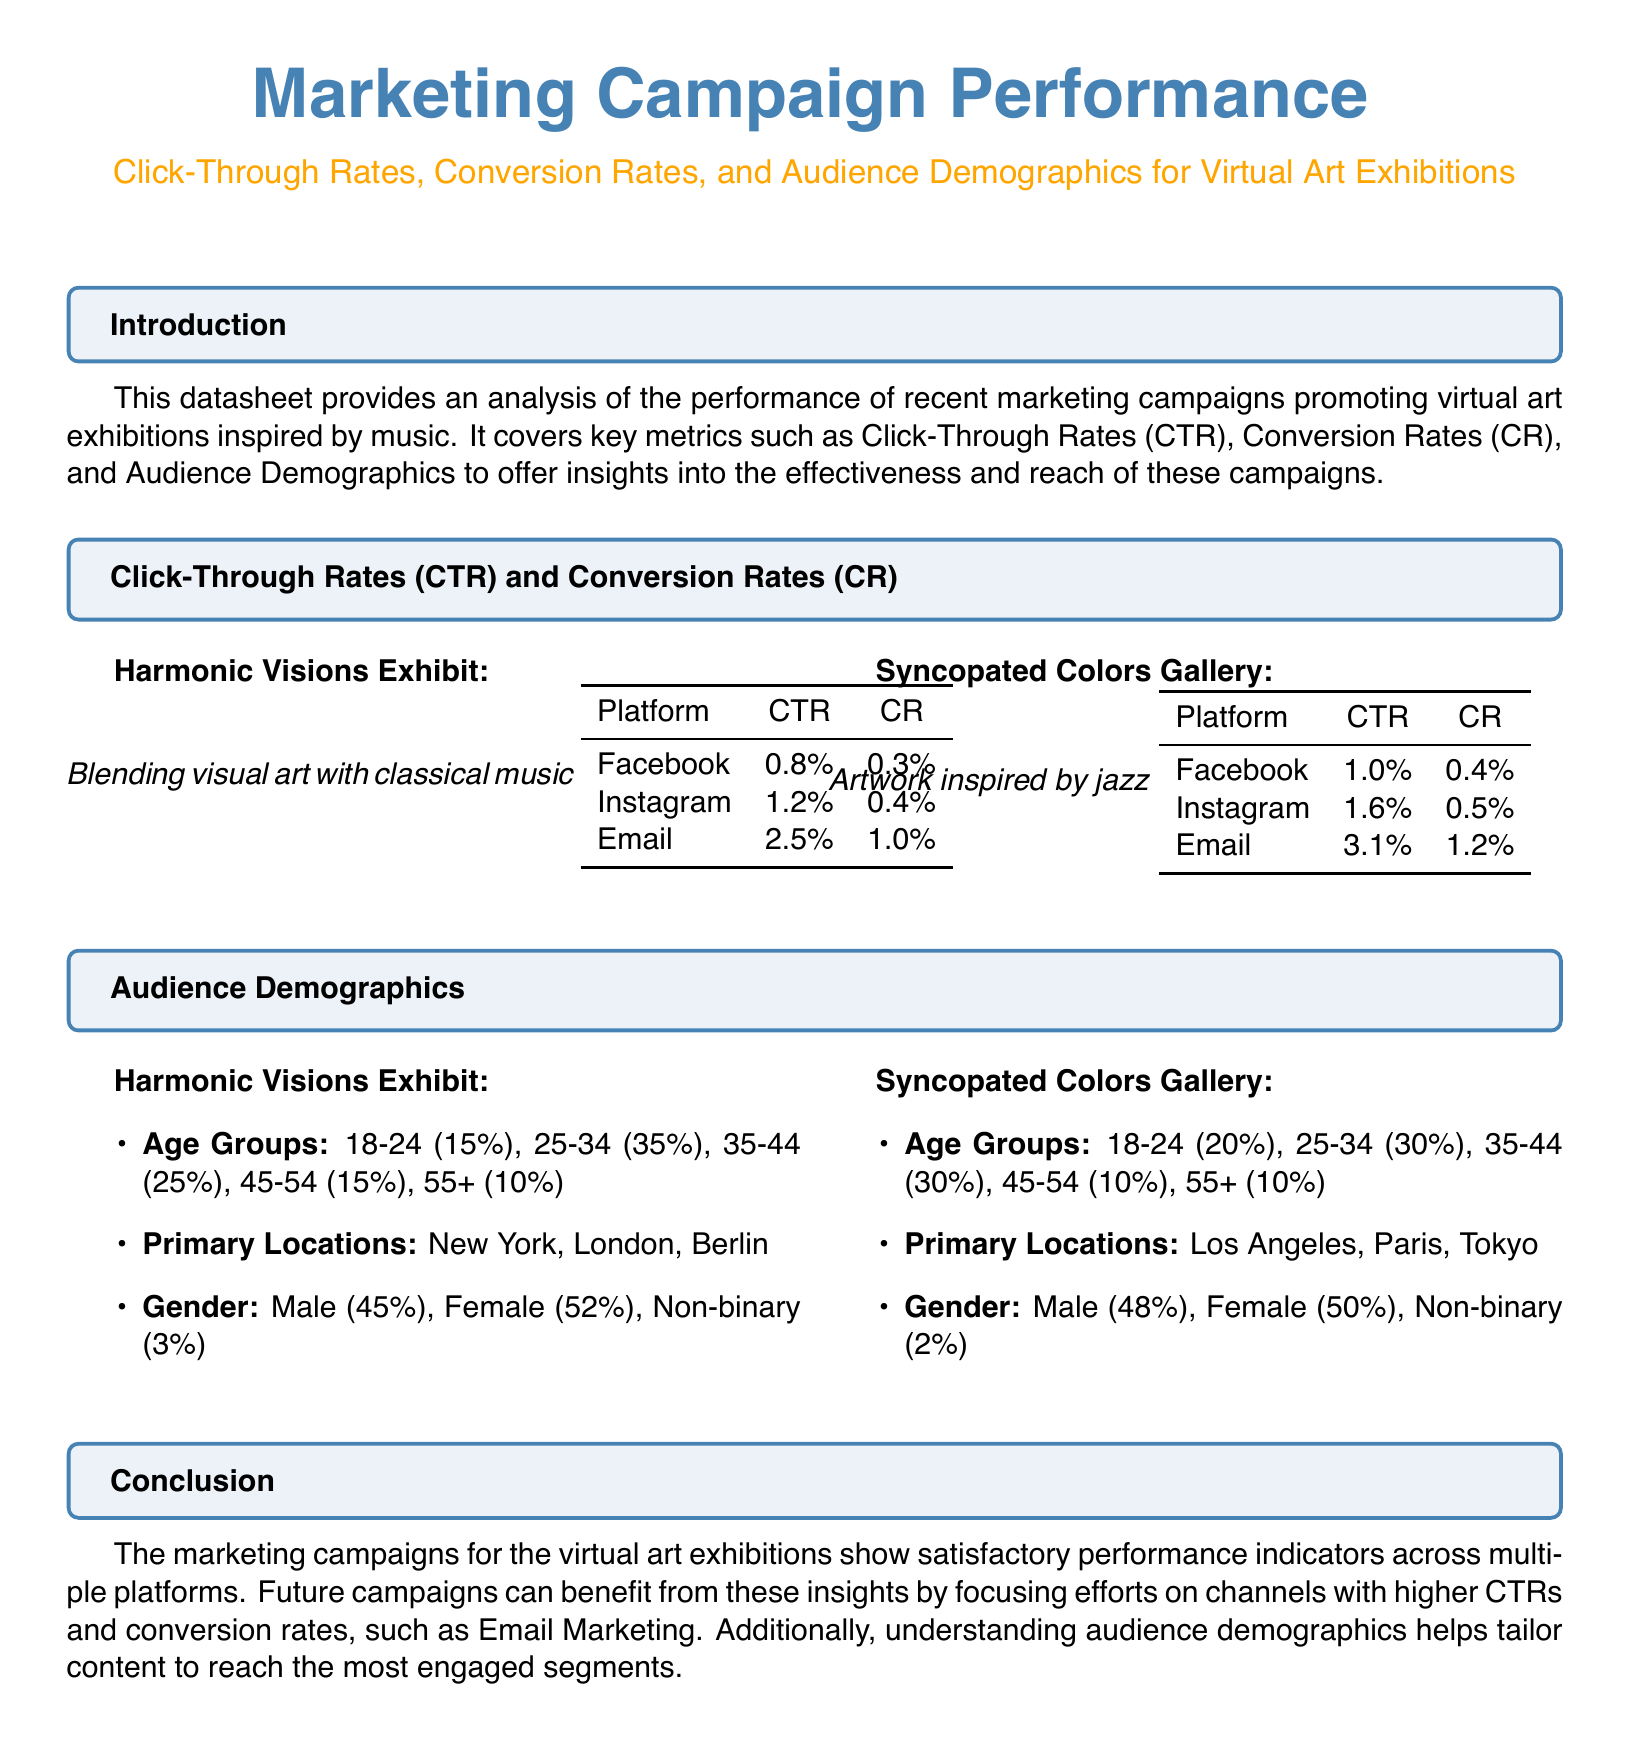What is the Click-Through Rate (CTR) for Email in the Harmonic Visions Exhibit? The CTR for Email in the Harmonic Visions Exhibit is provided in the table, which states it is 2.5%.
Answer: 2.5% What is the Conversion Rate (CR) for Instagram in the Syncopated Colors Gallery? The CR for Instagram in the Syncopated Colors Gallery can be found in the table, which shows it is 0.5%.
Answer: 0.5% What age group has the highest percentage in the Harmonic Visions Exhibit? The highest percentage age group in the Harmonic Visions Exhibit is 25-34, which is 35%.
Answer: 25-34 Which platform has the highest Click-Through Rate (CTR) overall? By comparing the CTRs across the two exhibits, Email has the highest CTR at 3.1%.
Answer: Email What is the gender distribution of non-binary individuals in the Harmonic Visions Exhibit? The gender distribution for non-binary individuals in the Harmonic Visions Exhibit is specified as 3%.
Answer: 3% Which city is a primary location for the Syncopated Colors Gallery? The primary locations for the Syncopated Colors Gallery include Los Angeles, Paris, and Tokyo.
Answer: Los Angeles How do the Conversion Rates (CR) of Email compare between the two exhibits? Comparing the email CRs, 1.0% in Harmonic Visions and 1.2% in Syncopated Colors shows that Syncopated Colors has a slightly higher rate.
Answer: Syncopated Colors What percentage of the audience is aged 45-54 in the Syncopated Colors Gallery? The percentage of the audience aged 45-54 in the Syncopated Colors Gallery is listed as 10%.
Answer: 10% 